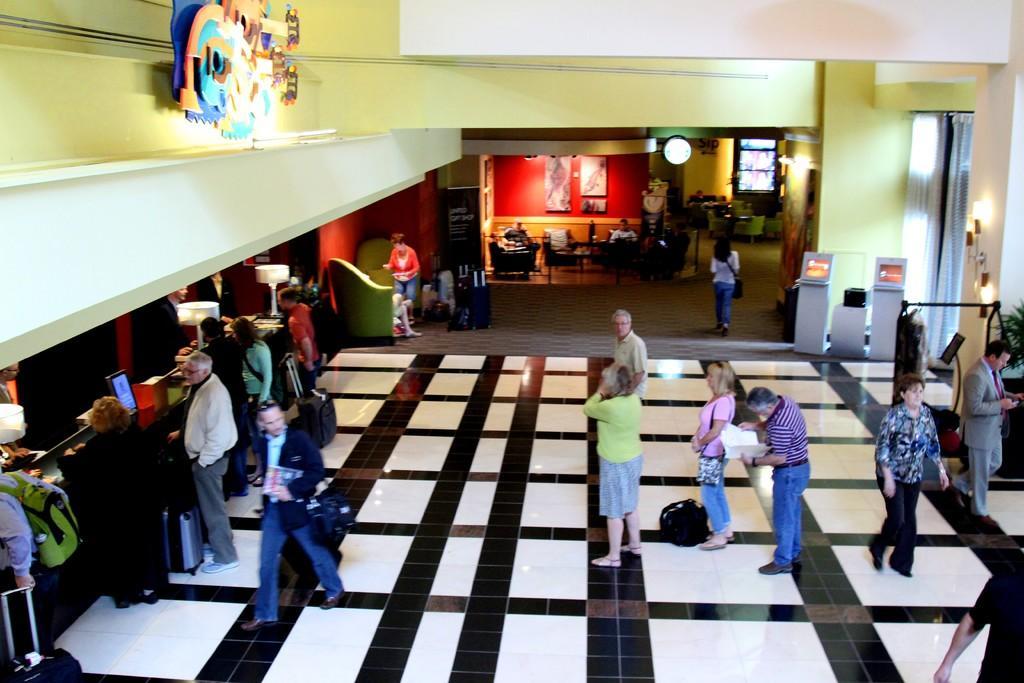In one or two sentences, can you explain what this image depicts? As we can see in the image there is a wall, few people here and there, white and black color tiles, photo frames, lamps and laptops. 